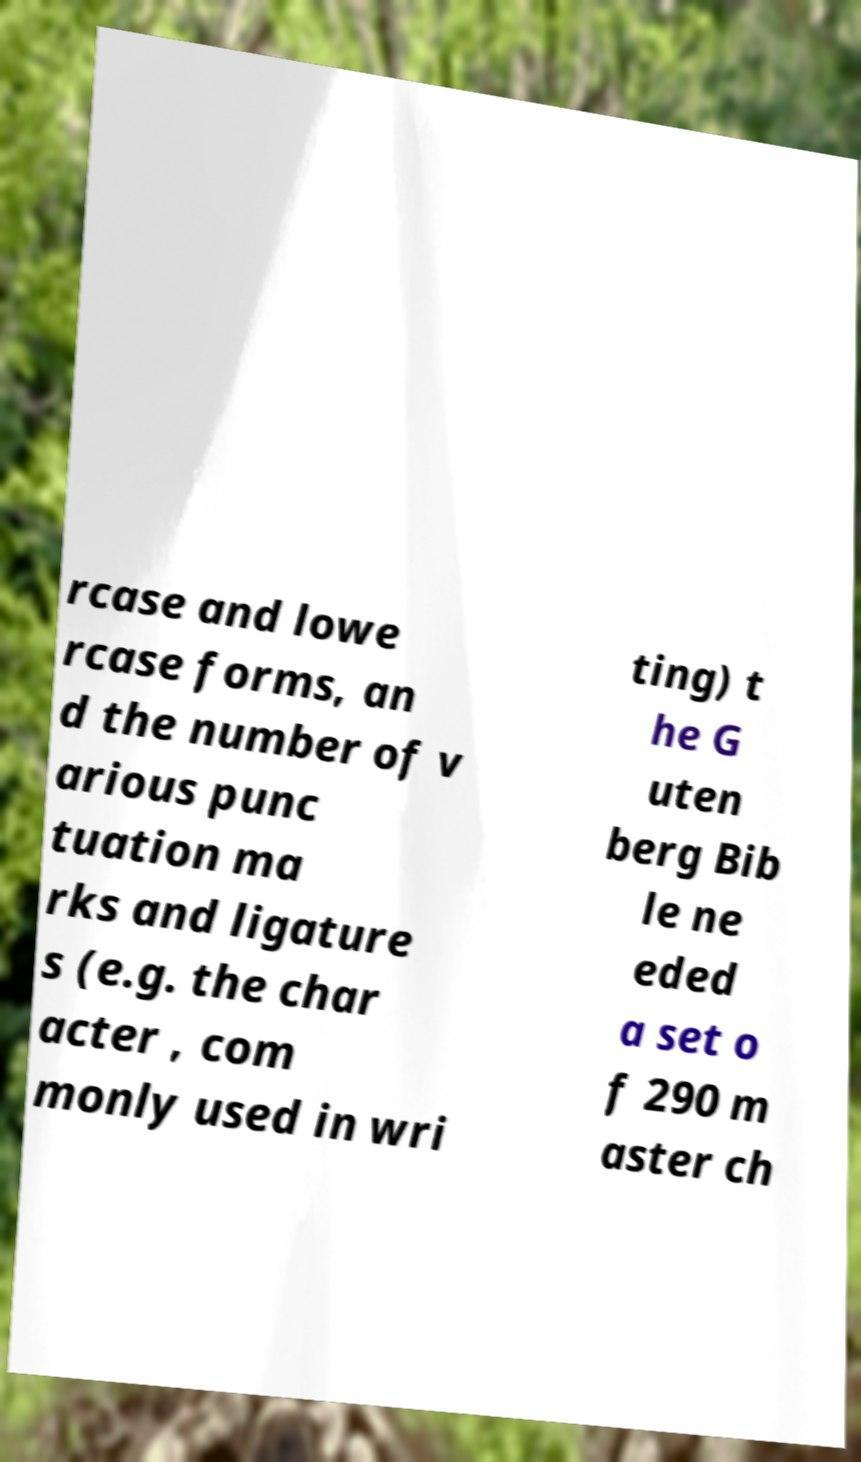Can you accurately transcribe the text from the provided image for me? rcase and lowe rcase forms, an d the number of v arious punc tuation ma rks and ligature s (e.g. the char acter , com monly used in wri ting) t he G uten berg Bib le ne eded a set o f 290 m aster ch 